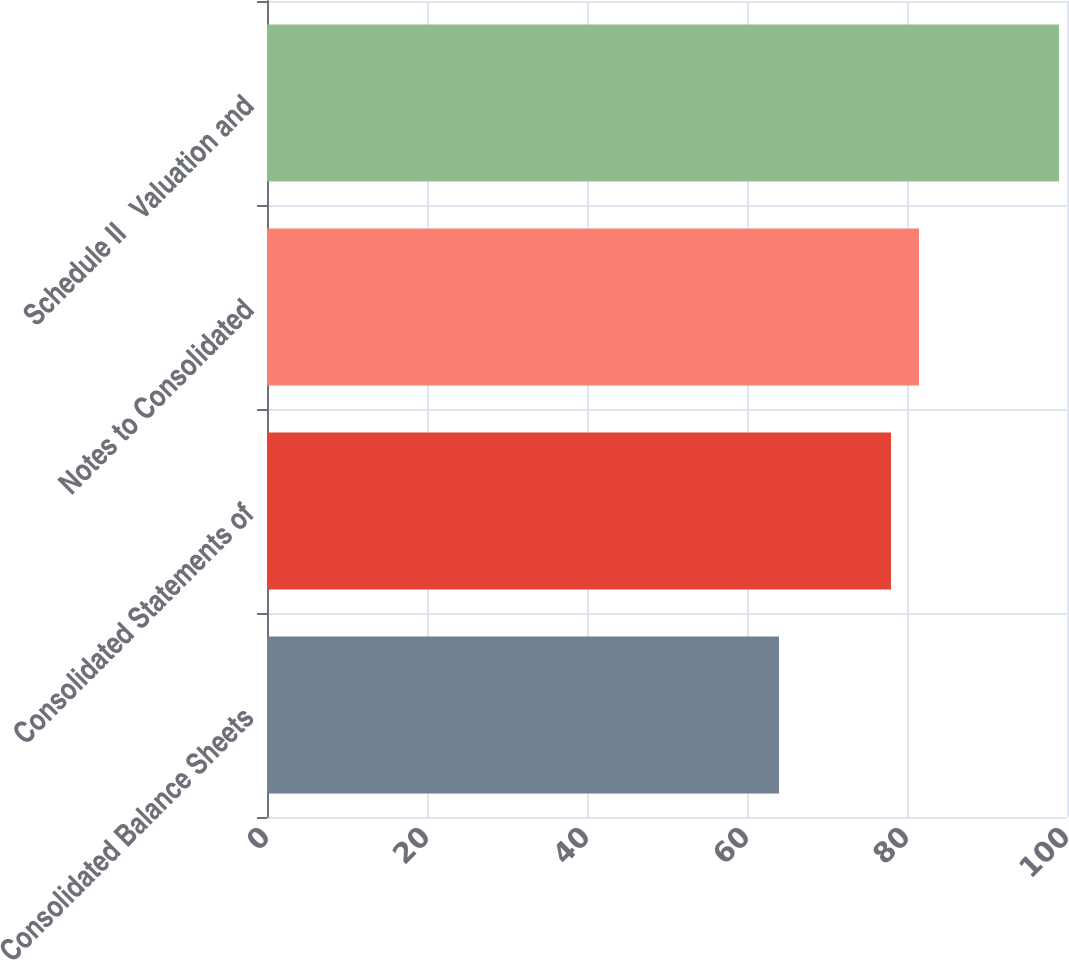Convert chart to OTSL. <chart><loc_0><loc_0><loc_500><loc_500><bar_chart><fcel>Consolidated Balance Sheets<fcel>Consolidated Statements of<fcel>Notes to Consolidated<fcel>Schedule II  Valuation and<nl><fcel>64<fcel>78<fcel>81.5<fcel>99<nl></chart> 